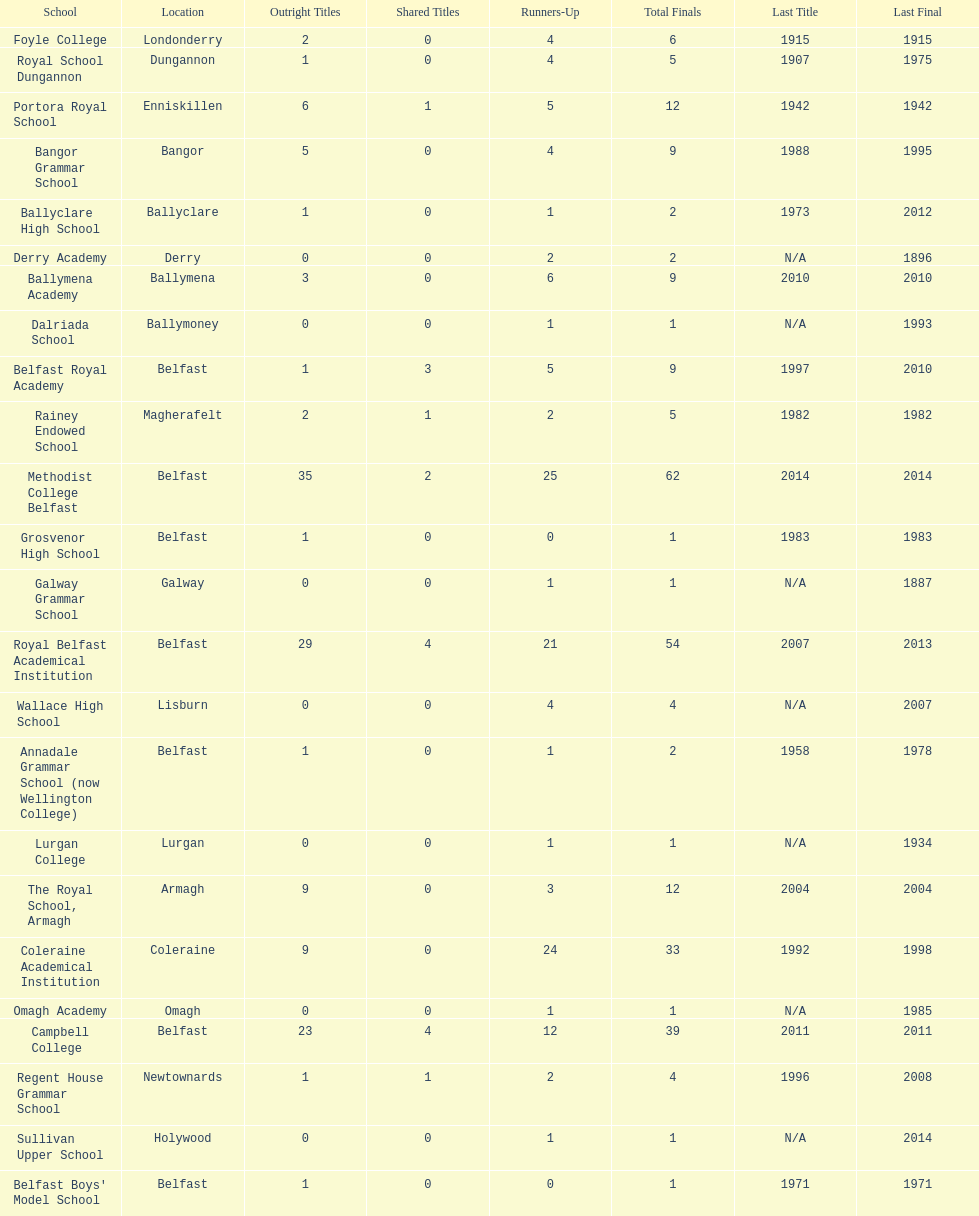Was the total number of final matches at belfast royal academy higher or lower than that at ballyclare high school? More. 